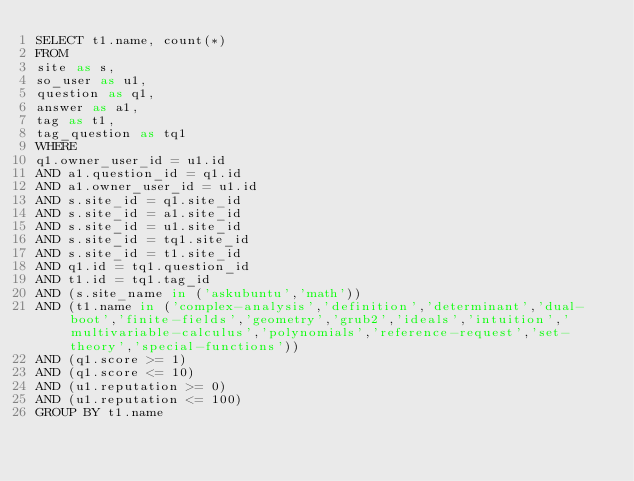<code> <loc_0><loc_0><loc_500><loc_500><_SQL_>SELECT t1.name, count(*)
FROM
site as s,
so_user as u1,
question as q1,
answer as a1,
tag as t1,
tag_question as tq1
WHERE
q1.owner_user_id = u1.id
AND a1.question_id = q1.id
AND a1.owner_user_id = u1.id
AND s.site_id = q1.site_id
AND s.site_id = a1.site_id
AND s.site_id = u1.site_id
AND s.site_id = tq1.site_id
AND s.site_id = t1.site_id
AND q1.id = tq1.question_id
AND t1.id = tq1.tag_id
AND (s.site_name in ('askubuntu','math'))
AND (t1.name in ('complex-analysis','definition','determinant','dual-boot','finite-fields','geometry','grub2','ideals','intuition','multivariable-calculus','polynomials','reference-request','set-theory','special-functions'))
AND (q1.score >= 1)
AND (q1.score <= 10)
AND (u1.reputation >= 0)
AND (u1.reputation <= 100)
GROUP BY t1.name</code> 